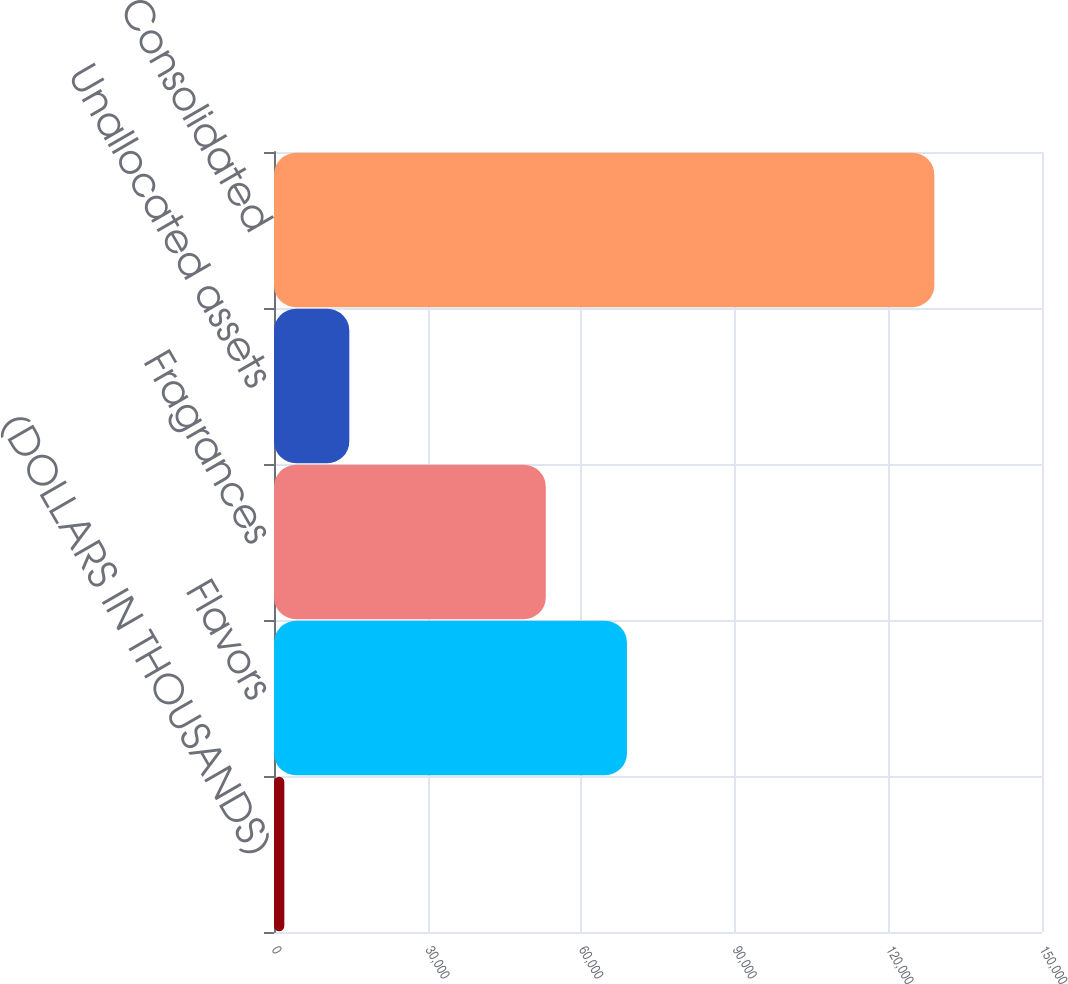<chart> <loc_0><loc_0><loc_500><loc_500><bar_chart><fcel>(DOLLARS IN THOUSANDS)<fcel>Flavors<fcel>Fragrances<fcel>Unallocated assets<fcel>Consolidated<nl><fcel>2017<fcel>68937<fcel>53089<fcel>14712.6<fcel>128973<nl></chart> 